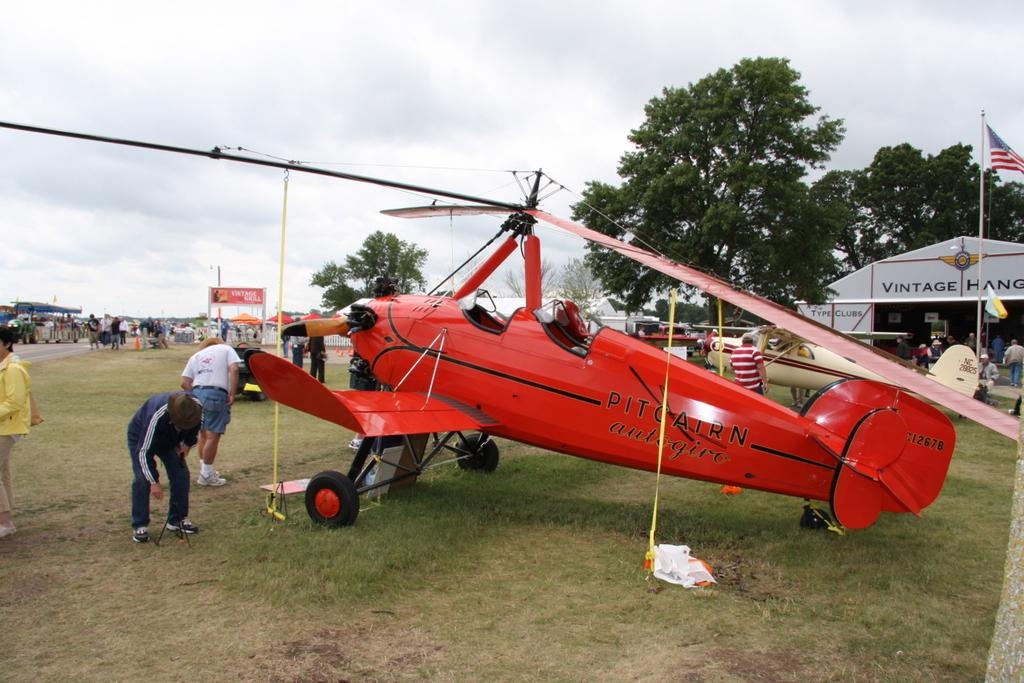What is the main subject of the image? The main subject of the image is aircrafts. Can you describe the people in the image? Yes, there are persons in the image. What type of temporary shelters can be seen in the image? There are tents in the image. What is located on the right side of the image? There are trees on the right side of the image. What type of structure is present in the image? There is a shed in the image. Is there any text visible on the shed? Yes, there is text on the shed. What is visible at the top of the image? The sky is visible at the top of the image. What type of paste is being used by the persons in the image? There is no paste visible in the image, and no indication that the persons are using any paste. 